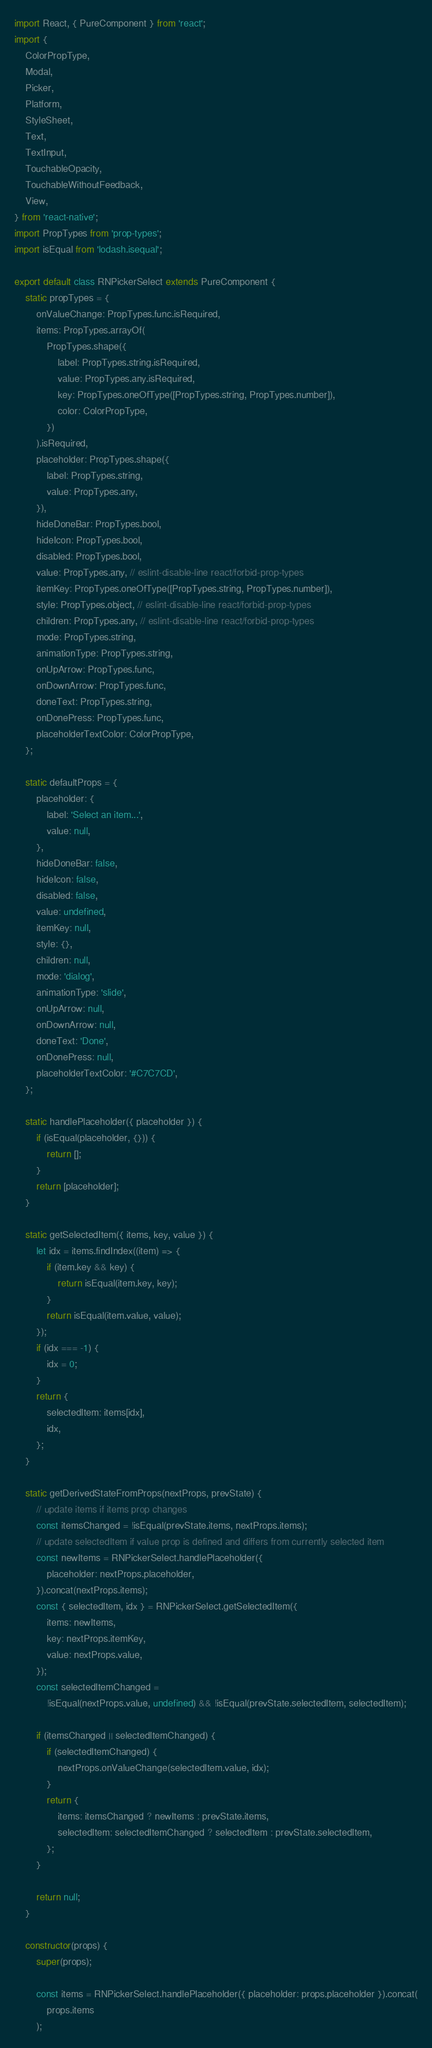<code> <loc_0><loc_0><loc_500><loc_500><_JavaScript_>import React, { PureComponent } from 'react';
import {
    ColorPropType,
    Modal,
    Picker,
    Platform,
    StyleSheet,
    Text,
    TextInput,
    TouchableOpacity,
    TouchableWithoutFeedback,
    View,
} from 'react-native';
import PropTypes from 'prop-types';
import isEqual from 'lodash.isequal';

export default class RNPickerSelect extends PureComponent {
    static propTypes = {
        onValueChange: PropTypes.func.isRequired,
        items: PropTypes.arrayOf(
            PropTypes.shape({
                label: PropTypes.string.isRequired,
                value: PropTypes.any.isRequired,
                key: PropTypes.oneOfType([PropTypes.string, PropTypes.number]),
                color: ColorPropType,
            })
        ).isRequired,
        placeholder: PropTypes.shape({
            label: PropTypes.string,
            value: PropTypes.any,
        }),
        hideDoneBar: PropTypes.bool,
        hideIcon: PropTypes.bool,
        disabled: PropTypes.bool,
        value: PropTypes.any, // eslint-disable-line react/forbid-prop-types
        itemKey: PropTypes.oneOfType([PropTypes.string, PropTypes.number]),
        style: PropTypes.object, // eslint-disable-line react/forbid-prop-types
        children: PropTypes.any, // eslint-disable-line react/forbid-prop-types
        mode: PropTypes.string,
        animationType: PropTypes.string,
        onUpArrow: PropTypes.func,
        onDownArrow: PropTypes.func,
        doneText: PropTypes.string,
        onDonePress: PropTypes.func,
        placeholderTextColor: ColorPropType,
    };

    static defaultProps = {
        placeholder: {
            label: 'Select an item...',
            value: null,
        },
        hideDoneBar: false,
        hideIcon: false,
        disabled: false,
        value: undefined,
        itemKey: null,
        style: {},
        children: null,
        mode: 'dialog',
        animationType: 'slide',
        onUpArrow: null,
        onDownArrow: null,
        doneText: 'Done',
        onDonePress: null,
        placeholderTextColor: '#C7C7CD',
    };

    static handlePlaceholder({ placeholder }) {
        if (isEqual(placeholder, {})) {
            return [];
        }
        return [placeholder];
    }

    static getSelectedItem({ items, key, value }) {
        let idx = items.findIndex((item) => {
            if (item.key && key) {
                return isEqual(item.key, key);
            }
            return isEqual(item.value, value);
        });
        if (idx === -1) {
            idx = 0;
        }
        return {
            selectedItem: items[idx],
            idx,
        };
    }

    static getDerivedStateFromProps(nextProps, prevState) {
        // update items if items prop changes
        const itemsChanged = !isEqual(prevState.items, nextProps.items);
        // update selectedItem if value prop is defined and differs from currently selected item
        const newItems = RNPickerSelect.handlePlaceholder({
            placeholder: nextProps.placeholder,
        }).concat(nextProps.items);
        const { selectedItem, idx } = RNPickerSelect.getSelectedItem({
            items: newItems,
            key: nextProps.itemKey,
            value: nextProps.value,
        });
        const selectedItemChanged =
            !isEqual(nextProps.value, undefined) && !isEqual(prevState.selectedItem, selectedItem);

        if (itemsChanged || selectedItemChanged) {
            if (selectedItemChanged) {
                nextProps.onValueChange(selectedItem.value, idx);
            }
            return {
                items: itemsChanged ? newItems : prevState.items,
                selectedItem: selectedItemChanged ? selectedItem : prevState.selectedItem,
            };
        }

        return null;
    }

    constructor(props) {
        super(props);

        const items = RNPickerSelect.handlePlaceholder({ placeholder: props.placeholder }).concat(
            props.items
        );</code> 